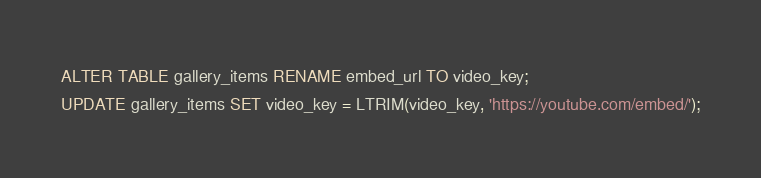Convert code to text. <code><loc_0><loc_0><loc_500><loc_500><_SQL_>ALTER TABLE gallery_items RENAME embed_url TO video_key;
UPDATE gallery_items SET video_key = LTRIM(video_key, 'https://youtube.com/embed/');</code> 